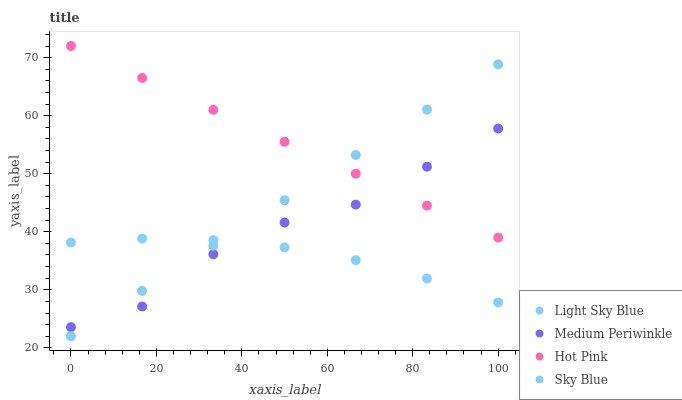Does Light Sky Blue have the minimum area under the curve?
Answer yes or no. Yes. Does Hot Pink have the maximum area under the curve?
Answer yes or no. Yes. Does Medium Periwinkle have the minimum area under the curve?
Answer yes or no. No. Does Medium Periwinkle have the maximum area under the curve?
Answer yes or no. No. Is Sky Blue the smoothest?
Answer yes or no. Yes. Is Medium Periwinkle the roughest?
Answer yes or no. Yes. Is Light Sky Blue the smoothest?
Answer yes or no. No. Is Light Sky Blue the roughest?
Answer yes or no. No. Does Sky Blue have the lowest value?
Answer yes or no. Yes. Does Light Sky Blue have the lowest value?
Answer yes or no. No. Does Hot Pink have the highest value?
Answer yes or no. Yes. Does Medium Periwinkle have the highest value?
Answer yes or no. No. Is Light Sky Blue less than Hot Pink?
Answer yes or no. Yes. Is Hot Pink greater than Light Sky Blue?
Answer yes or no. Yes. Does Light Sky Blue intersect Sky Blue?
Answer yes or no. Yes. Is Light Sky Blue less than Sky Blue?
Answer yes or no. No. Is Light Sky Blue greater than Sky Blue?
Answer yes or no. No. Does Light Sky Blue intersect Hot Pink?
Answer yes or no. No. 